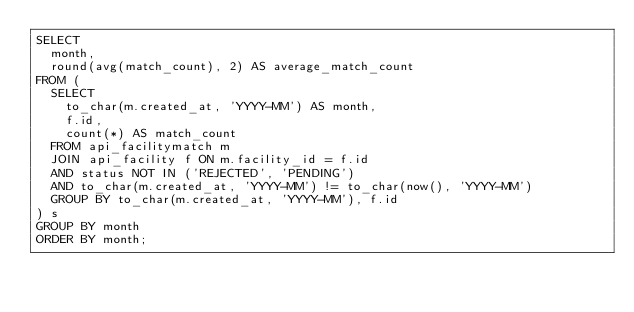Convert code to text. <code><loc_0><loc_0><loc_500><loc_500><_SQL_>SELECT
  month,
  round(avg(match_count), 2) AS average_match_count
FROM (
  SELECT
    to_char(m.created_at, 'YYYY-MM') AS month,
    f.id,
    count(*) AS match_count
  FROM api_facilitymatch m
  JOIN api_facility f ON m.facility_id = f.id
  AND status NOT IN ('REJECTED', 'PENDING')
  AND to_char(m.created_at, 'YYYY-MM') != to_char(now(), 'YYYY-MM')
  GROUP BY to_char(m.created_at, 'YYYY-MM'), f.id
) s
GROUP BY month
ORDER BY month;
</code> 